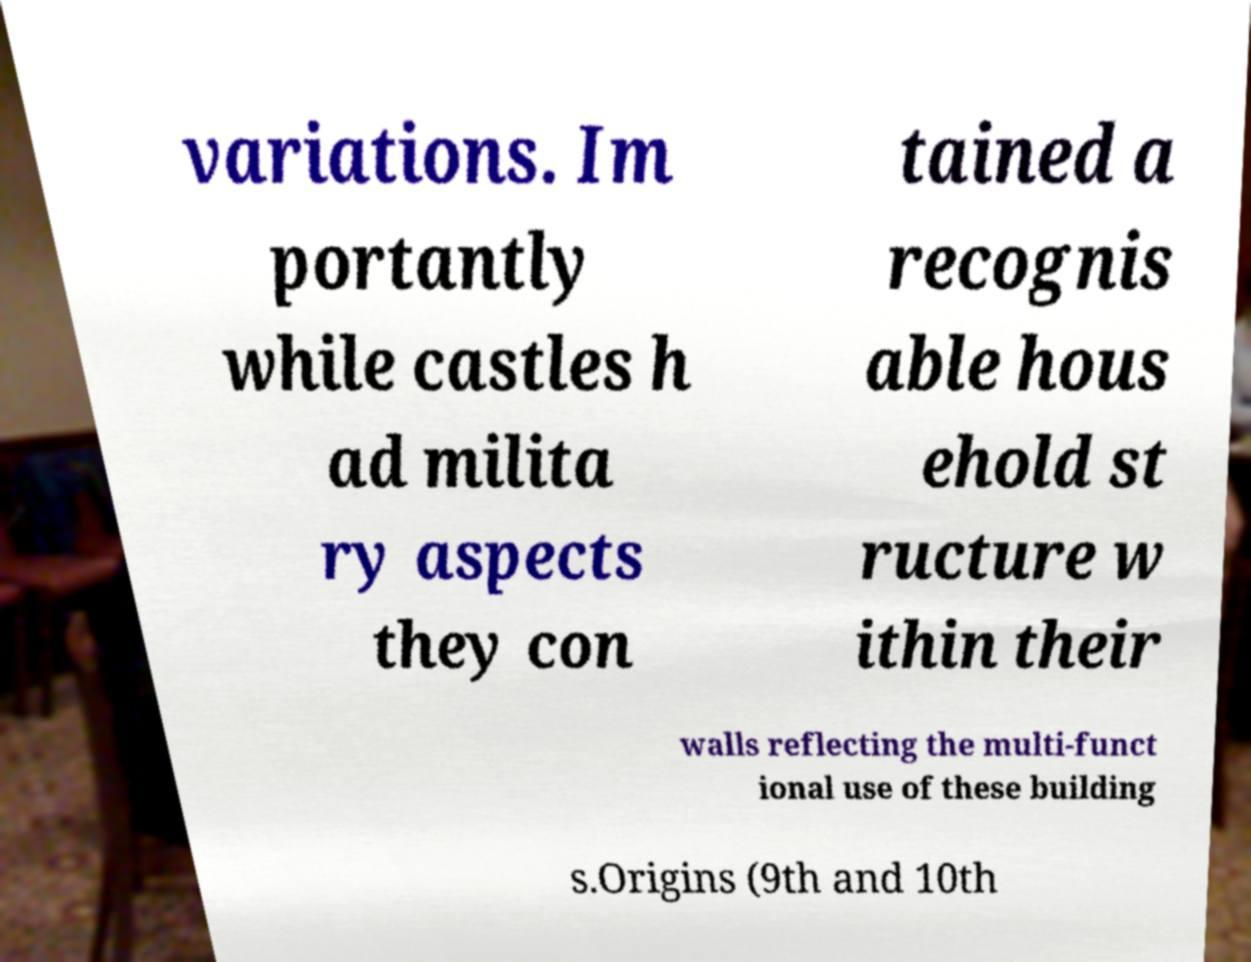There's text embedded in this image that I need extracted. Can you transcribe it verbatim? variations. Im portantly while castles h ad milita ry aspects they con tained a recognis able hous ehold st ructure w ithin their walls reflecting the multi-funct ional use of these building s.Origins (9th and 10th 